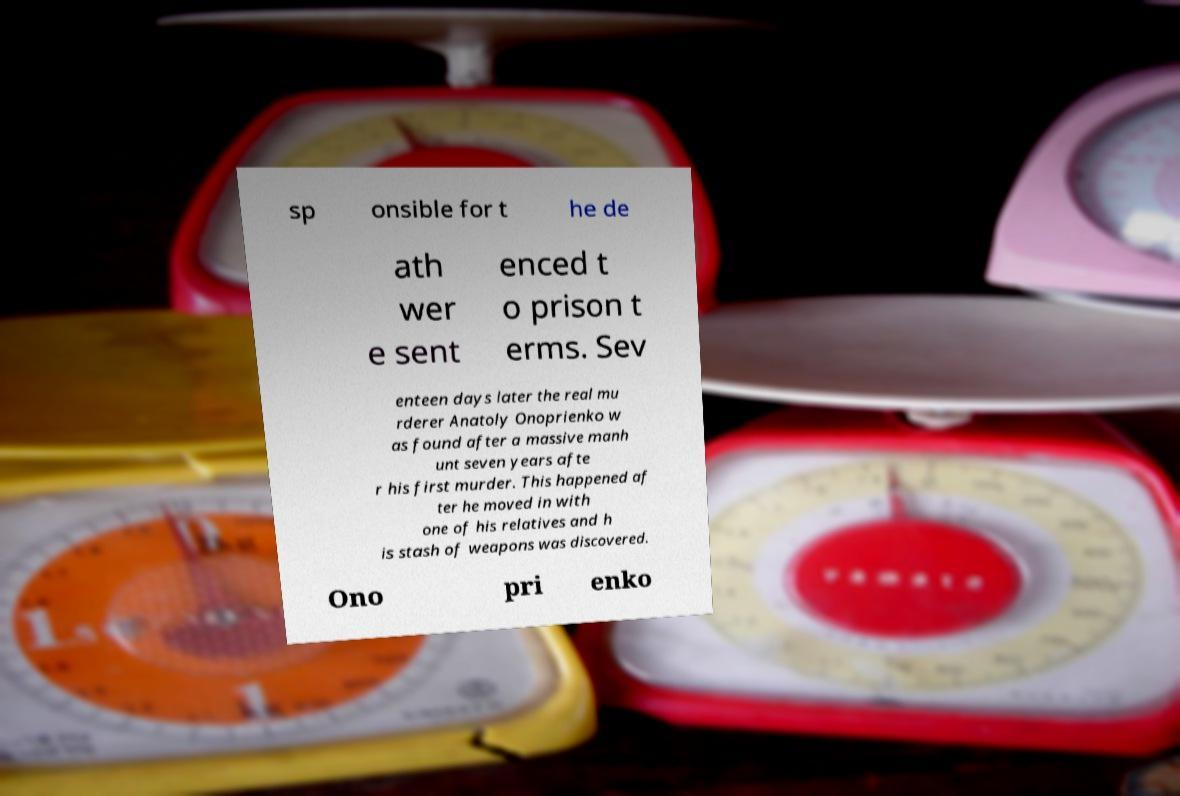For documentation purposes, I need the text within this image transcribed. Could you provide that? sp onsible for t he de ath wer e sent enced t o prison t erms. Sev enteen days later the real mu rderer Anatoly Onoprienko w as found after a massive manh unt seven years afte r his first murder. This happened af ter he moved in with one of his relatives and h is stash of weapons was discovered. Ono pri enko 